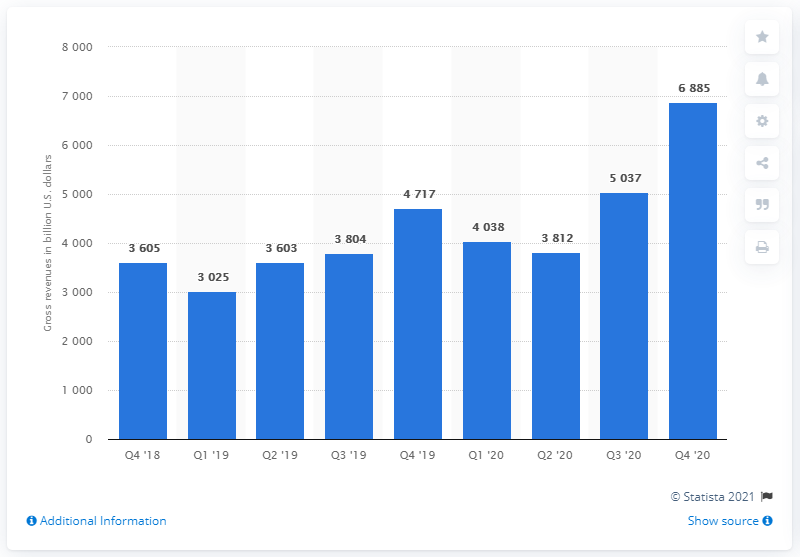Mention a couple of crucial points in this snapshot. In the fourth quarter of 2020, YouTube's worldwide advertising revenues were $68,850,000. 